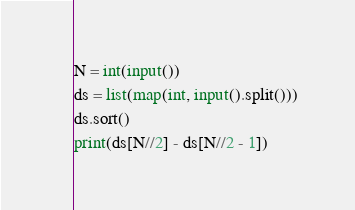Convert code to text. <code><loc_0><loc_0><loc_500><loc_500><_Python_>N = int(input())
ds = list(map(int, input().split()))
ds.sort()
print(ds[N//2] - ds[N//2 - 1])</code> 